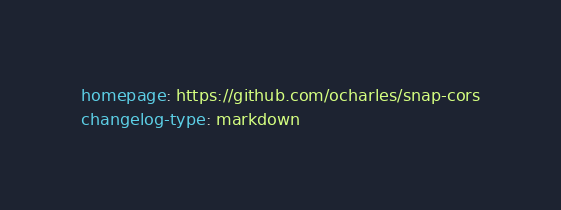Convert code to text. <code><loc_0><loc_0><loc_500><loc_500><_YAML_>homepage: https://github.com/ocharles/snap-cors
changelog-type: markdown</code> 